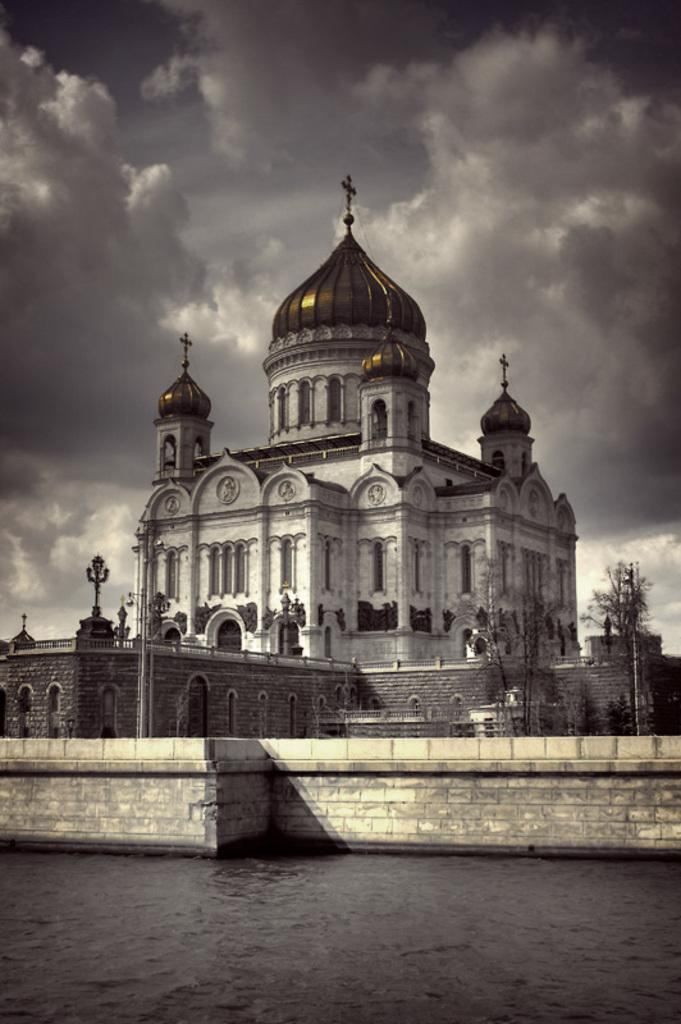What is the main structure in the center of the image? There is a palace in the center of the image. What is located at the bottom of the image? There is a wall and a lake at the bottom of the image. What can be seen in the background of the image? There are trees and the sky visible in the background of the image. What type of wine is being served at the palace in the image? There is no indication of wine or any serving activity in the image; it only shows a palace, a wall, a lake, trees, and the sky. 